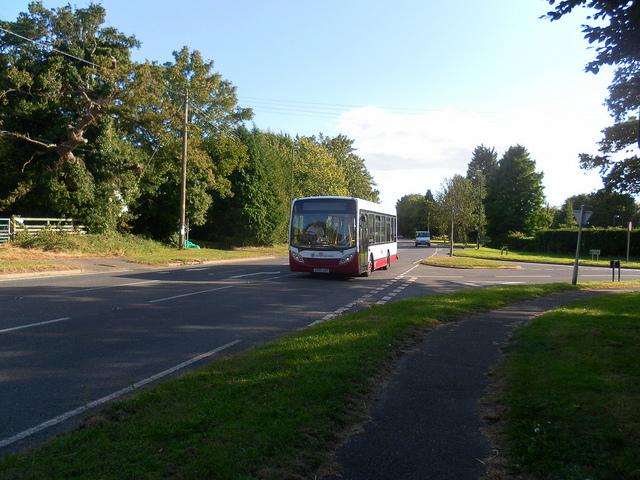What landforms are in the background?
Answer briefly. Trees. What is curving in the photo?
Write a very short answer. Sidewalk. Is there a traffic jam in this street?
Short answer required. No. Is the one way going right?
Write a very short answer. No. Could this be in England?
Write a very short answer. Yes. What type of transportation is headed toward the camera?
Write a very short answer. Bus. How many lanes of traffic are traveling in the same direction on the road to the right?
Give a very brief answer. 1. 